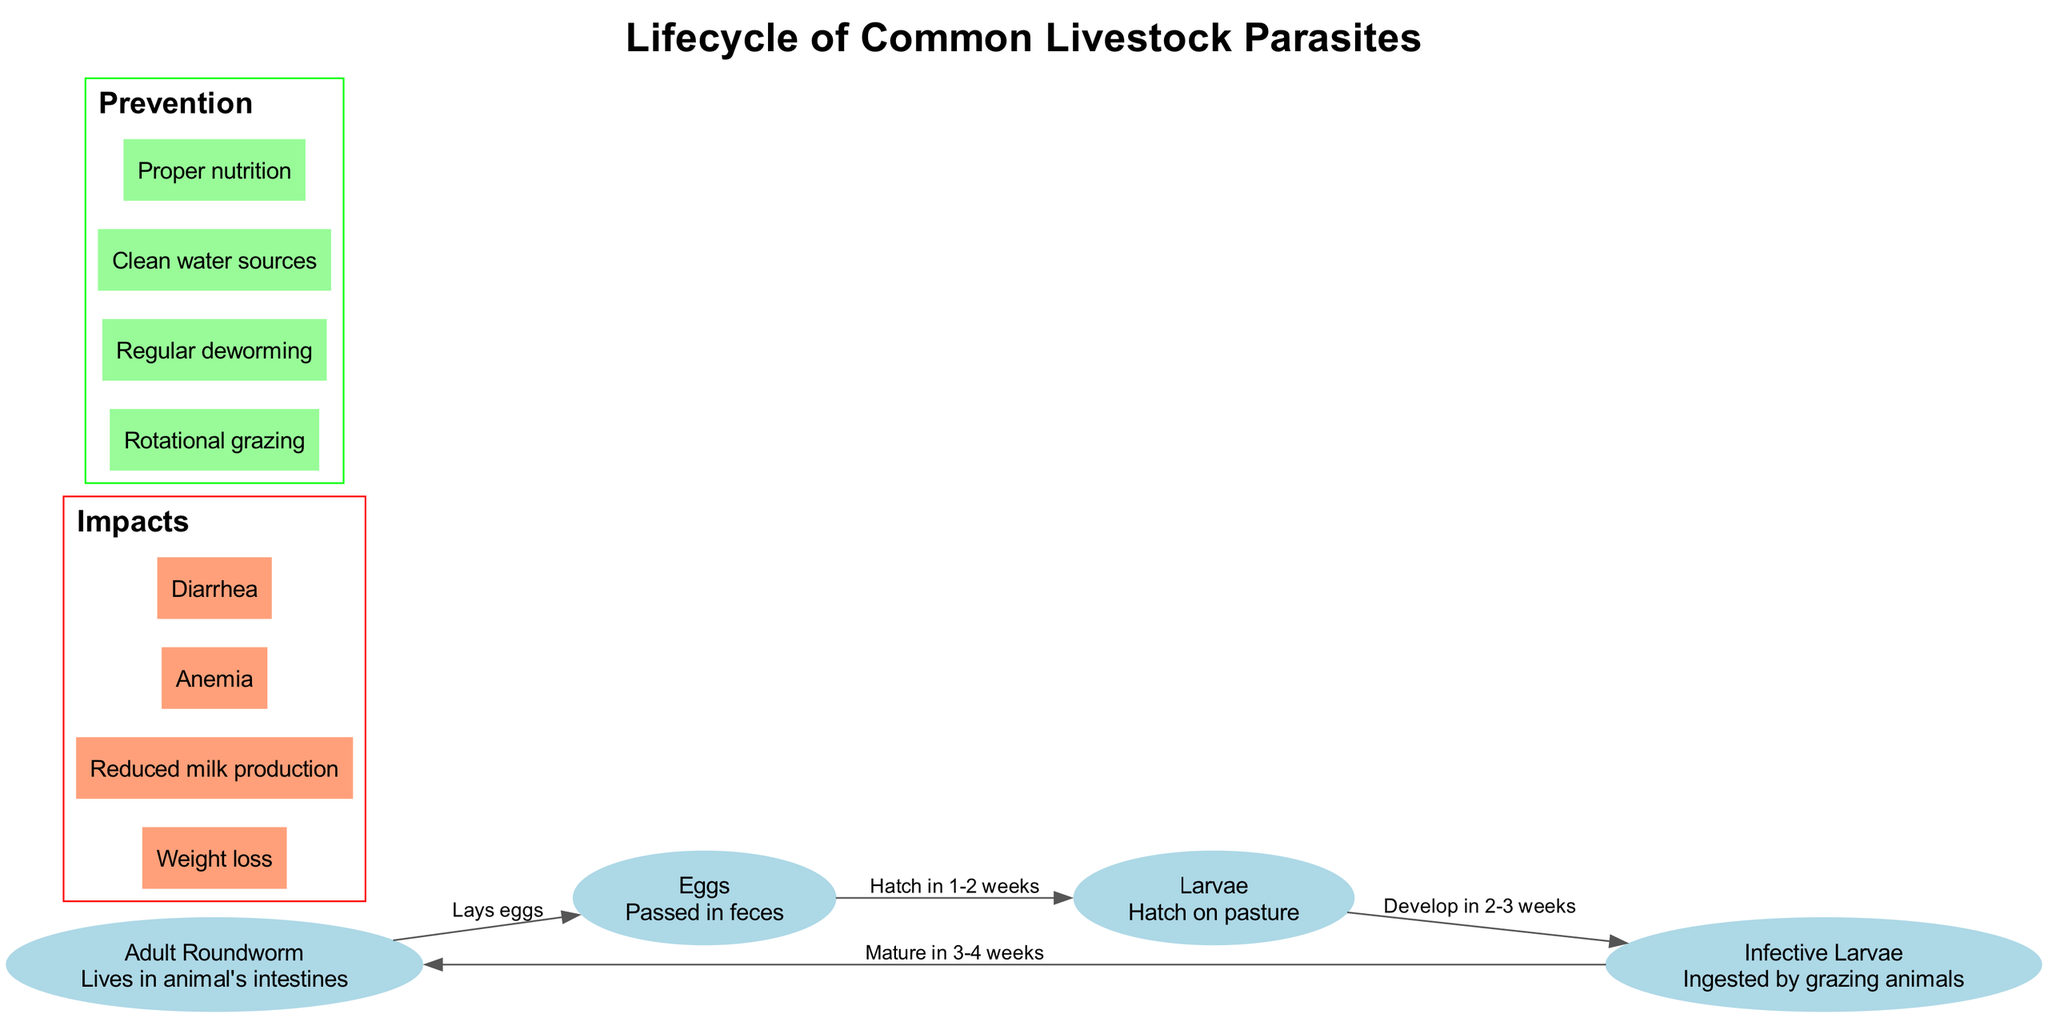What is the initial form of the parasite in the animal's intestines? The initial form of the parasite in the animal's intestines is the "Adult Roundworm", which is the starting point in the lifecycle diagram.
Answer: Adult Roundworm How long does it take for eggs to hatch on pasture? According to the diagram, it typically takes "1-2 weeks" for the eggs to hatch on the pasture after being passed in feces.
Answer: 1-2 weeks What type of larvae is ingested by grazing animals? The larvae type ingested by grazing animals is specified as "Infective Larvae" in the lifecycle diagram.
Answer: Infective Larvae What are the two major impacts of parasites on livestock health? The diagram lists several impacts, but two major ones are "Weight loss" and "Diarrhea". These impacts significantly affect livestock health.
Answer: Weight loss, Diarrhea How many distinct nodes represent stages in the parasite lifecycle? The diagram illustrates "4" distinct nodes that represent various stages in the lifecycle of the common livestock parasite.
Answer: 4 What relationship exists between the "Adult Roundworm" and "Eggs"? The relationship is that the "Adult Roundworm" lays the "Eggs", which is indicated as a directed edge in the lifecycle diagram.
Answer: Lays eggs Which prevention method is aimed at maintaining clean water sources? The prevention method that targets maintaining clean water sources is simply labeled as "Clean water sources" in the prevention section of the diagram.
Answer: Clean water sources What is the duration for larvae to develop on pasture? The diagram states that it takes "2-3 weeks" for the larvae to develop after hatching, as indicated in the lifecycle flow.
Answer: 2-3 weeks Which stage of the lifecycle matures after 3-4 weeks? According to the diagram, the "Infective Larvae" stage matures into the "Adult Roundworm" after a period of 3-4 weeks.
Answer: Adult Roundworm 